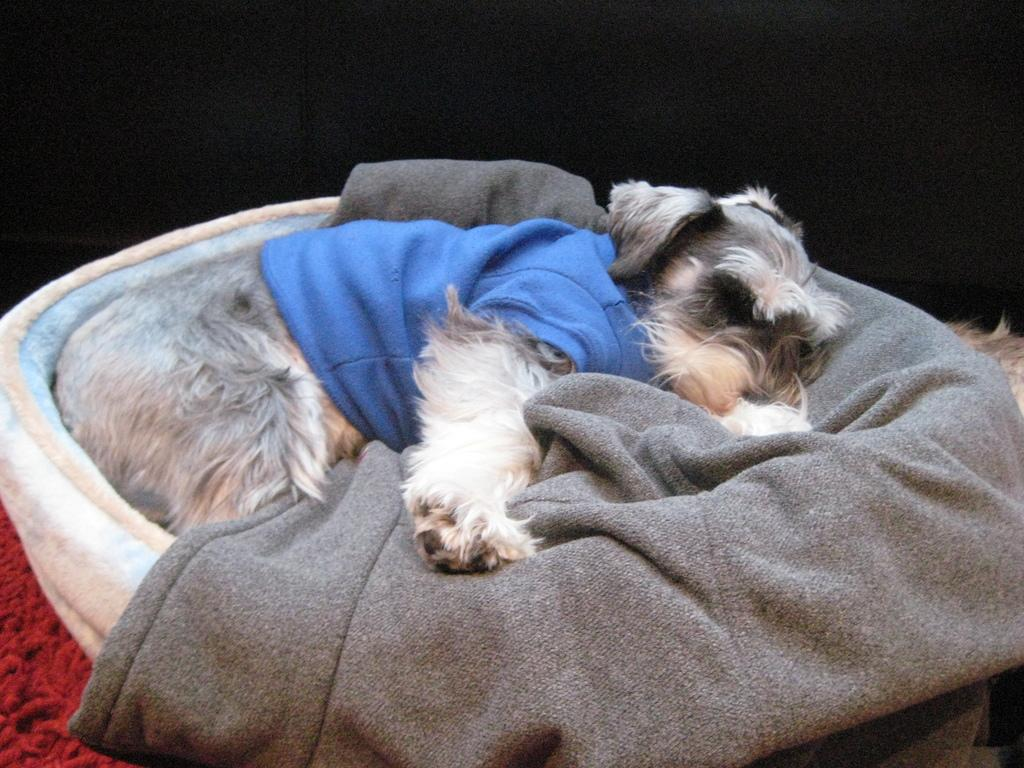What animal can be seen in the image? There is a dog in the image. What is the dog doing in the image? The dog is sleeping in a basket. What type of material is present in the image? There is a cloth in the image. Can you describe the object in the left side bottom corner of the image? There is a red object in the left side bottom corner of the image. What color is the background of the image? The background of the image is black. How many planes are flying in the background of the image? There are no planes visible in the image; the background is black. What type of feather can be seen on the dog's head in the image? There is no feather present on the dog's head in the image. 